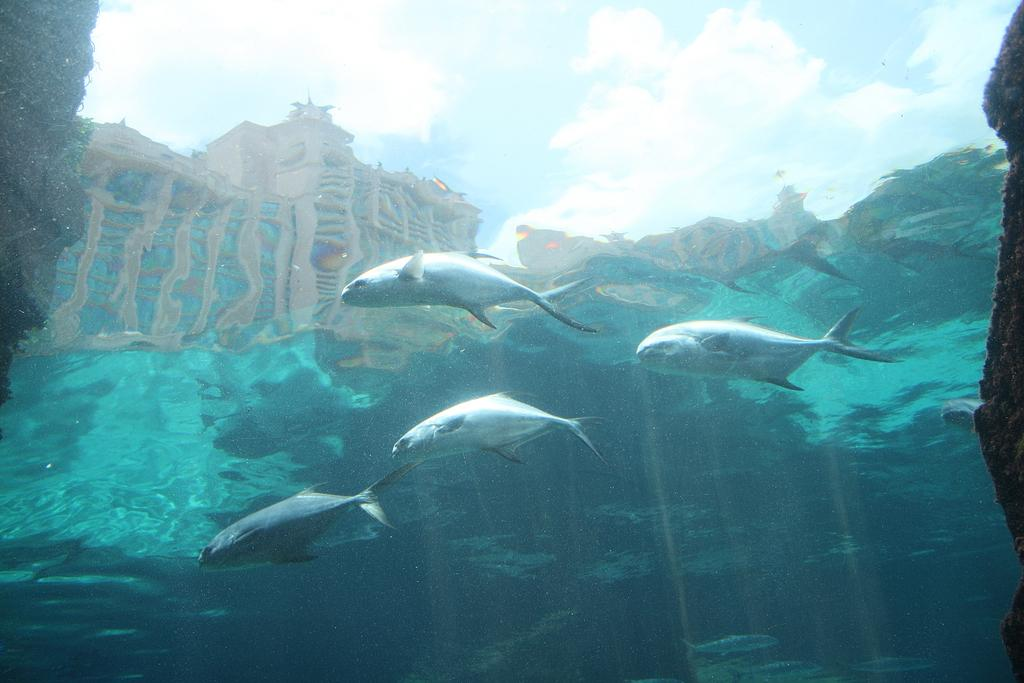What is the main subject of the image? The main subject of the image is an inside view of water. What can be seen swimming in the water? There are four fish in the water. What can be seen in the background of the image? There is a building and clouds visible in the background. What part of the natural environment is visible in the image? The sky is visible in the background. What type of coal is being used to provide comfort to the fish in the image? There is no coal present in the image, and the fish do not require comfort as they are in their natural environment. 